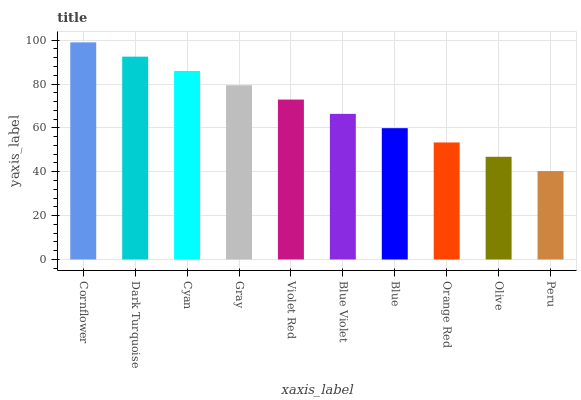Is Peru the minimum?
Answer yes or no. Yes. Is Cornflower the maximum?
Answer yes or no. Yes. Is Dark Turquoise the minimum?
Answer yes or no. No. Is Dark Turquoise the maximum?
Answer yes or no. No. Is Cornflower greater than Dark Turquoise?
Answer yes or no. Yes. Is Dark Turquoise less than Cornflower?
Answer yes or no. Yes. Is Dark Turquoise greater than Cornflower?
Answer yes or no. No. Is Cornflower less than Dark Turquoise?
Answer yes or no. No. Is Violet Red the high median?
Answer yes or no. Yes. Is Blue Violet the low median?
Answer yes or no. Yes. Is Cyan the high median?
Answer yes or no. No. Is Cornflower the low median?
Answer yes or no. No. 